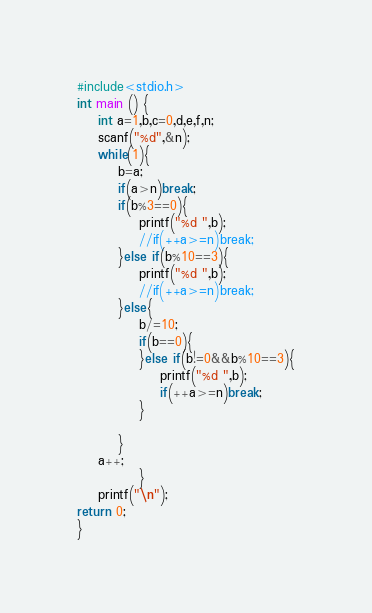<code> <loc_0><loc_0><loc_500><loc_500><_C_>#include<stdio.h>
int main () {
	int a=1,b,c=0,d,e,f,n;
	scanf("%d",&n);
	while(1){
		b=a;
		if(a>n)break;
		if(b%3==0){
			printf("%d ",b);
			//if(++a>=n)break;
		}else if(b%10==3){
			printf("%d ",b);
			//if(++a>=n)break;
		}else{
			b/=10;
			if(b==0){
			}else if(b!=0&&b%10==3){
				printf("%d ",b);
				if(++a>=n)break;
			}
		
		}
	a++;
			}
	printf("\n");
return 0;
}</code> 